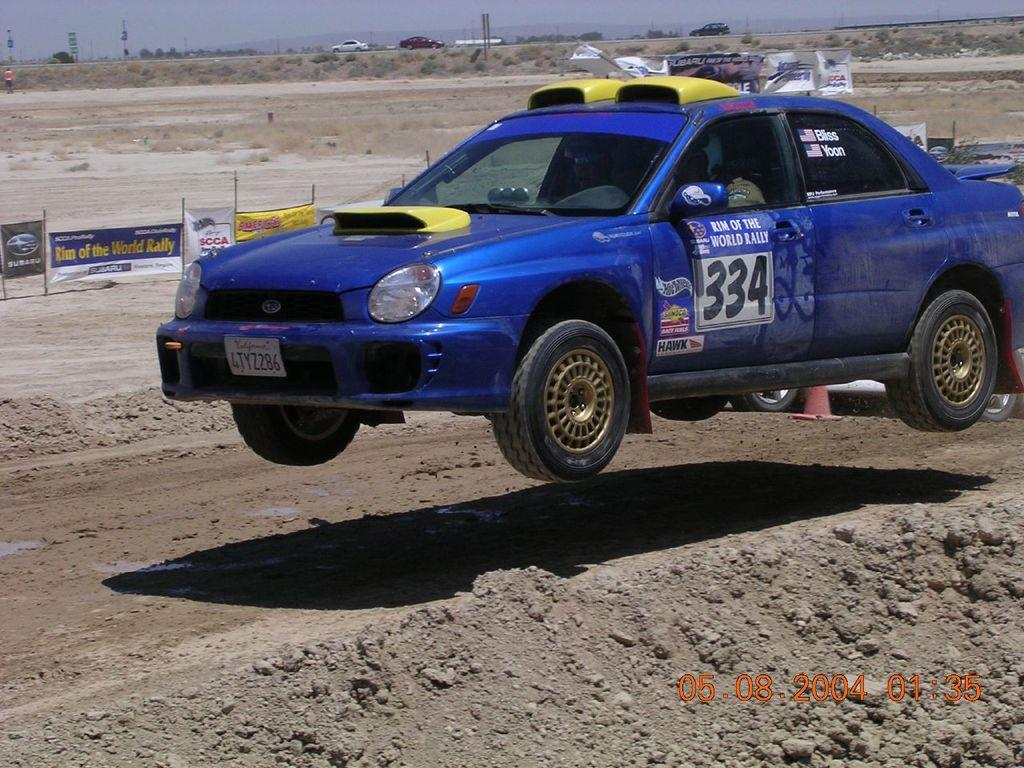What types of objects are present in the image? There are vehicles and advertising boards in the image. What can be seen in the background of the image? The sky is visible in the image. Are there any human figures in the image? Yes, there are people in the image. What type of chain is being used for teaching in the image? There is no chain or teaching activity present in the image. 